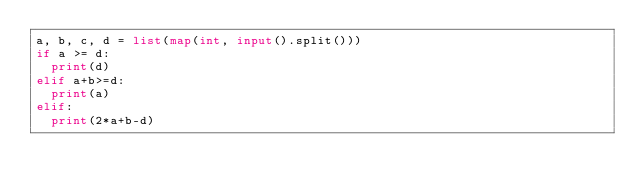Convert code to text. <code><loc_0><loc_0><loc_500><loc_500><_Python_>a, b, c, d = list(map(int, input().split()))
if a >= d:
  print(d)
elif a+b>=d:
  print(a)
elif:
  print(2*a+b-d)
</code> 